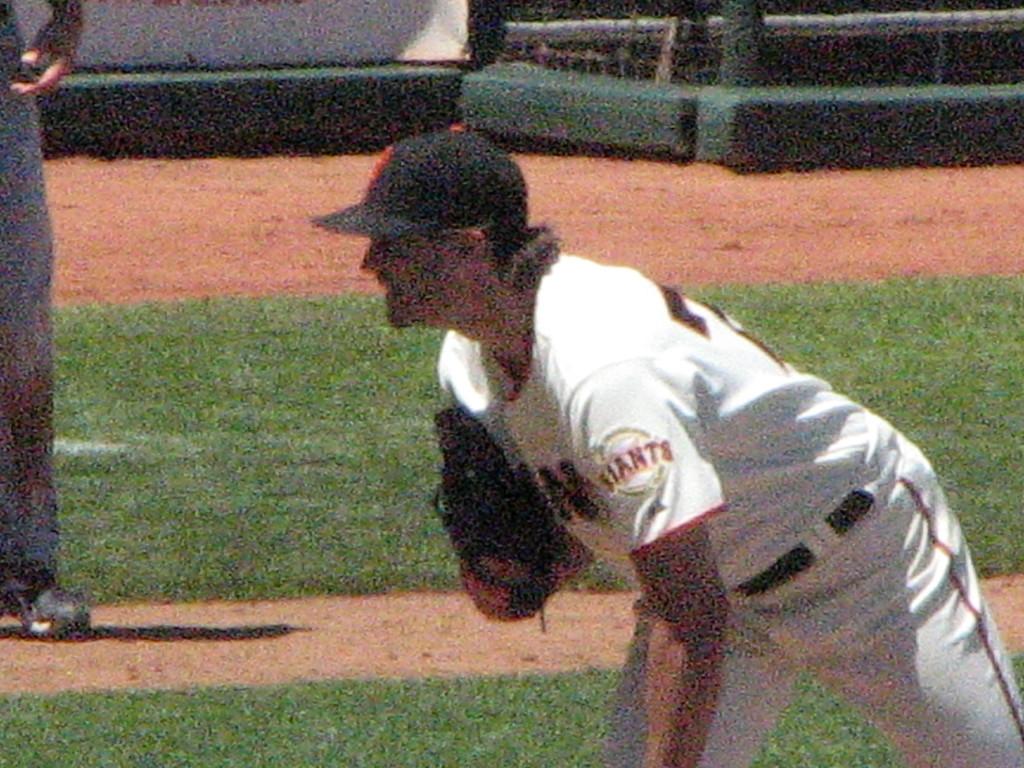Who does he play for?
Keep it short and to the point. Giants. 